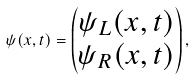Convert formula to latex. <formula><loc_0><loc_0><loc_500><loc_500>\psi ( { x } , t ) = \begin{pmatrix} \psi _ { L } ( { x } , t ) \\ \psi _ { R } ( { x } , t ) \end{pmatrix} ,</formula> 